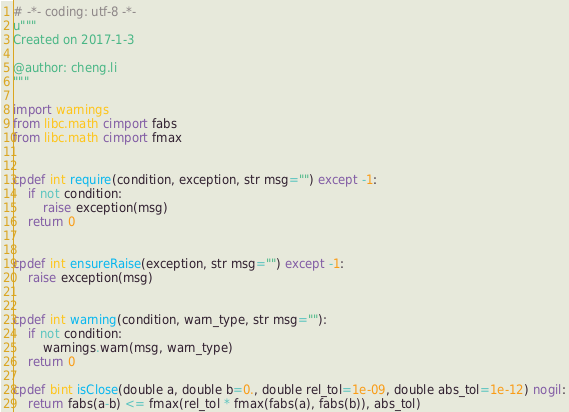Convert code to text. <code><loc_0><loc_0><loc_500><loc_500><_Cython_># -*- coding: utf-8 -*-
u"""
Created on 2017-1-3

@author: cheng.li
"""

import warnings
from libc.math cimport fabs
from libc.math cimport fmax


cpdef int require(condition, exception, str msg="") except -1:
    if not condition:
        raise exception(msg)
    return 0


cpdef int ensureRaise(exception, str msg="") except -1:
    raise exception(msg)


cpdef int warning(condition, warn_type, str msg=""):
    if not condition:
        warnings.warn(msg, warn_type)
    return 0

cpdef bint isClose(double a, double b=0., double rel_tol=1e-09, double abs_tol=1e-12) nogil:
    return fabs(a-b) <= fmax(rel_tol * fmax(fabs(a), fabs(b)), abs_tol)
</code> 